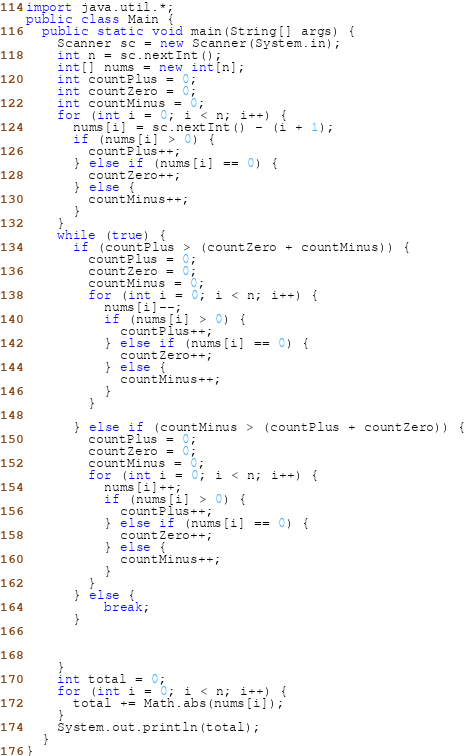Convert code to text. <code><loc_0><loc_0><loc_500><loc_500><_Java_>import java.util.*;
public class Main {
  public static void main(String[] args) {
    Scanner sc = new Scanner(System.in);
    int n = sc.nextInt();
    int[] nums = new int[n];
    int countPlus = 0;
    int countZero = 0;
    int countMinus = 0;
    for (int i = 0; i < n; i++) {
      nums[i] = sc.nextInt() - (i + 1);
      if (nums[i] > 0) {
        countPlus++;
      } else if (nums[i] == 0) {
        countZero++;
      } else {
        countMinus++;
      }
    }
    while (true) {
      if (countPlus > (countZero + countMinus)) {
        countPlus = 0;
        countZero = 0;
        countMinus = 0;
        for (int i = 0; i < n; i++) {
          nums[i]--;
          if (nums[i] > 0) {
            countPlus++;
          } else if (nums[i] == 0) {
            countZero++;
          } else {
            countMinus++;
          }
        }
     
      } else if (countMinus > (countPlus + countZero)) {
        countPlus = 0;
        countZero = 0;
        countMinus = 0;
        for (int i = 0; i < n; i++) {
          nums[i]++;
          if (nums[i] > 0) {
            countPlus++;
          } else if (nums[i] == 0) {
            countZero++;
          } else {
            countMinus++;
          }
        }
      } else {
          break;
      }

    
    
    }
    int total = 0;
    for (int i = 0; i < n; i++) {
      total += Math.abs(nums[i]);
    }
    System.out.println(total);
  }
}</code> 